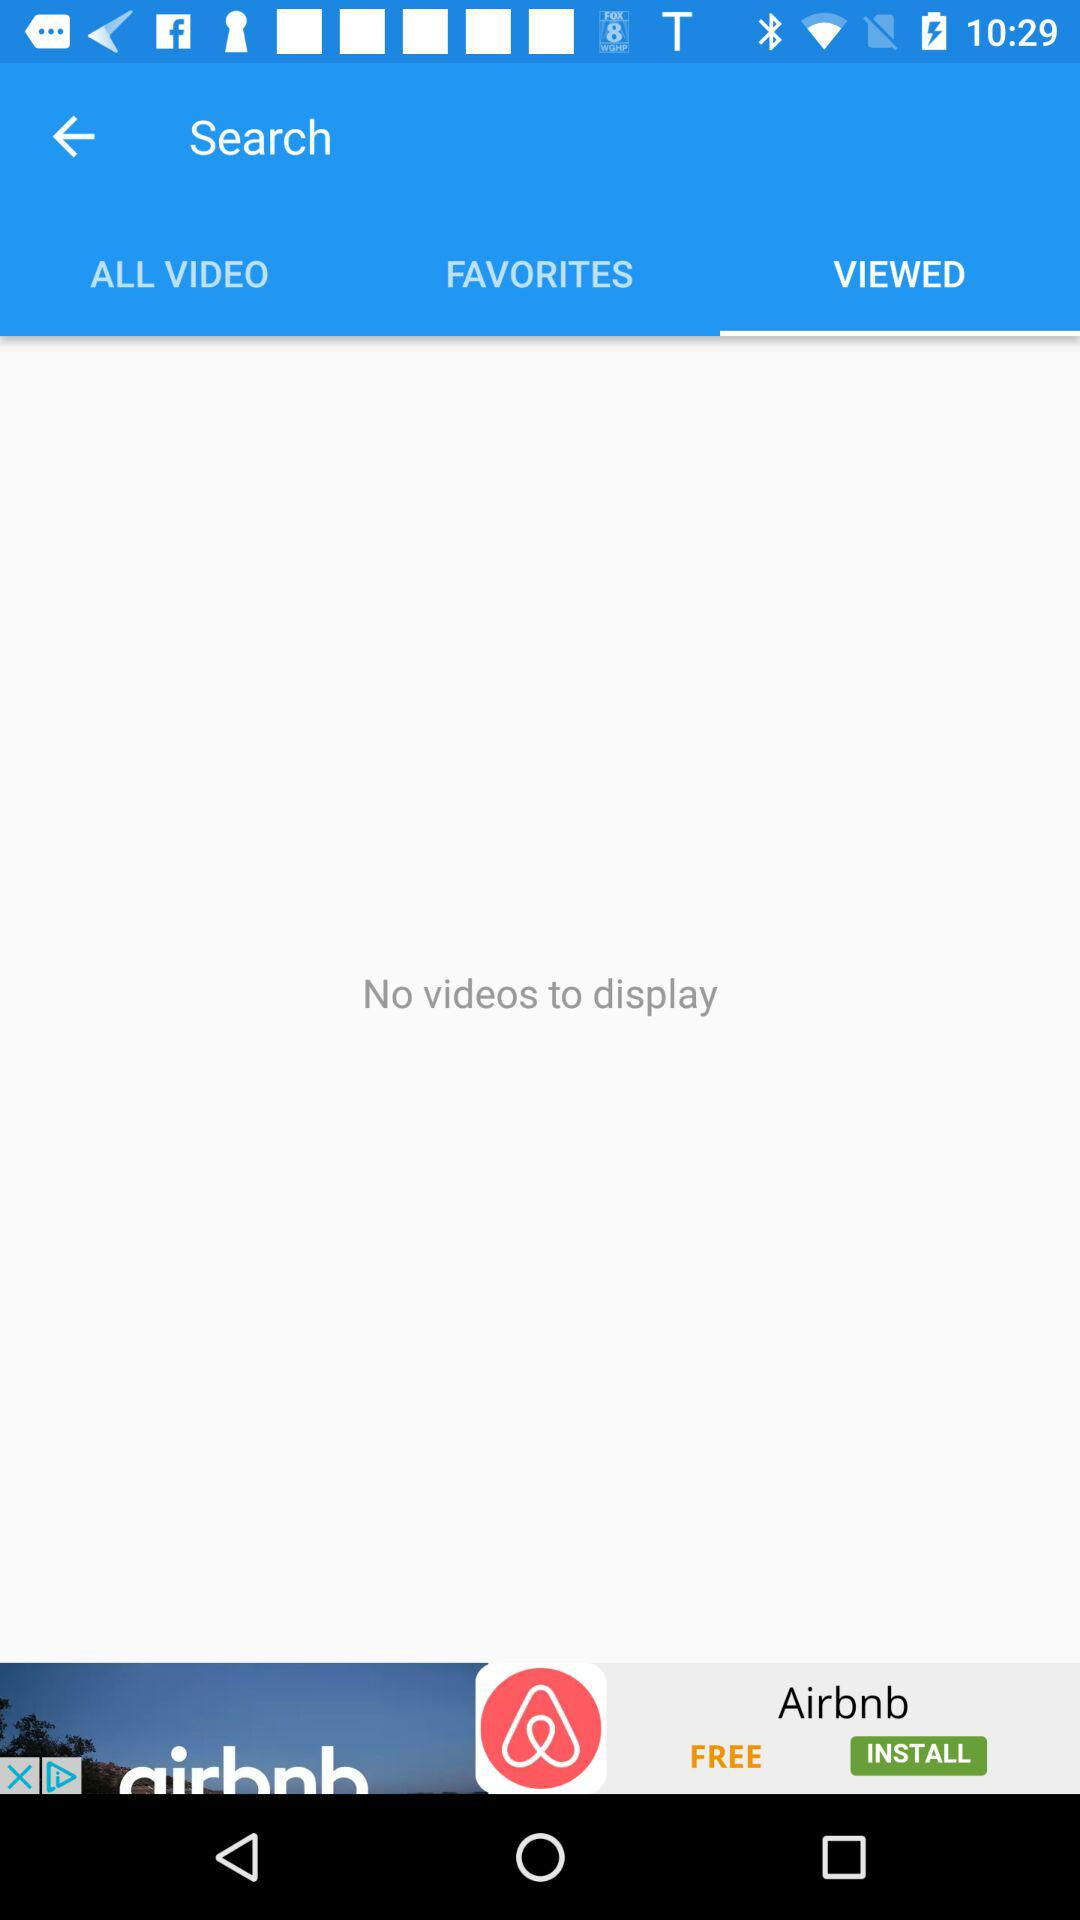How many notifications are there in "ALL VIDEO"?
When the provided information is insufficient, respond with <no answer>. <no answer> 